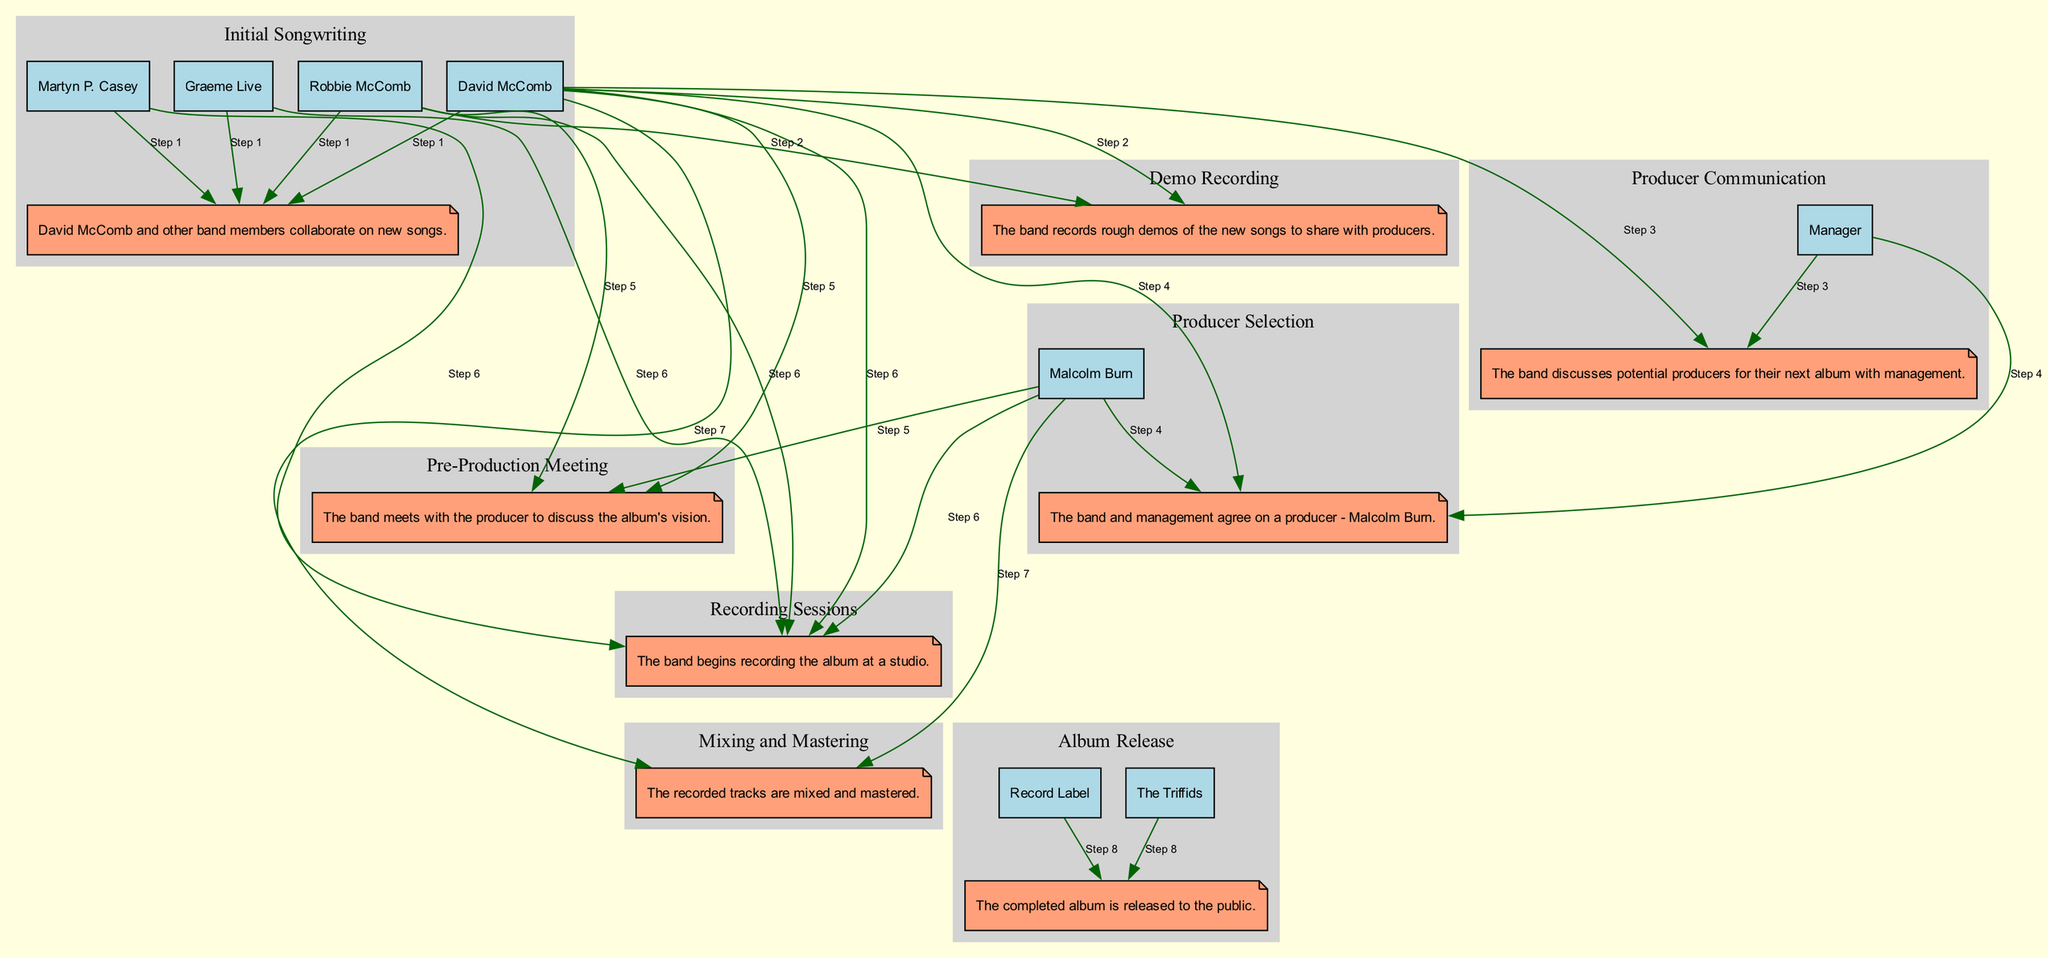What's the first event in the sequence? The first event listed in the diagram is "Initial Songwriting," where David McComb and the band members collaborate on new songs.
Answer: Initial Songwriting How many participants are involved in the "Pre-Production Meeting" event? The "Pre-Production Meeting" involves three participants: David McComb, Robbie McComb, and Malcolm Burn.
Answer: 3 Who is the producer selected for the album? According to the diagram, the producer selected for the album is Malcolm Burn, as indicated in the "Producer Selection" event.
Answer: Malcolm Burn What is the last event in the sequence? The last event in the diagram is "Album Release," which signifies when the completed album is released to the public.
Answer: Album Release Which event involves the mixing of recorded tracks? The event that involves the mixing of recorded tracks is "Mixing and Mastering." This event is directly tied to the audio production phase after recording.
Answer: Mixing and Mastering What event directly follows "Demo Recording" in the sequence? The event that directly follows "Demo Recording" is "Producer Communication," as shown in the chronological flow of events.
Answer: Producer Communication How many events include David McComb as a participant? David McComb is a participant in six events: "Initial Songwriting," "Demo Recording," "Producer Communication," "Producer Selection," "Pre-Production Meeting," and "Recording Sessions."
Answer: 6 Which two events involve communication with the producer? The two events that involve communication with the producer are "Producer Selection" and "Pre-Production Meeting." These events indicate interactions with Malcolm Burn.
Answer: Producer Selection, Pre-Production Meeting What step follows the "Recording Sessions"? The step that follows "Recording Sessions" is "Mixing and Mastering," indicating the process of finalizing the audio tracks.
Answer: Mixing and Mastering 